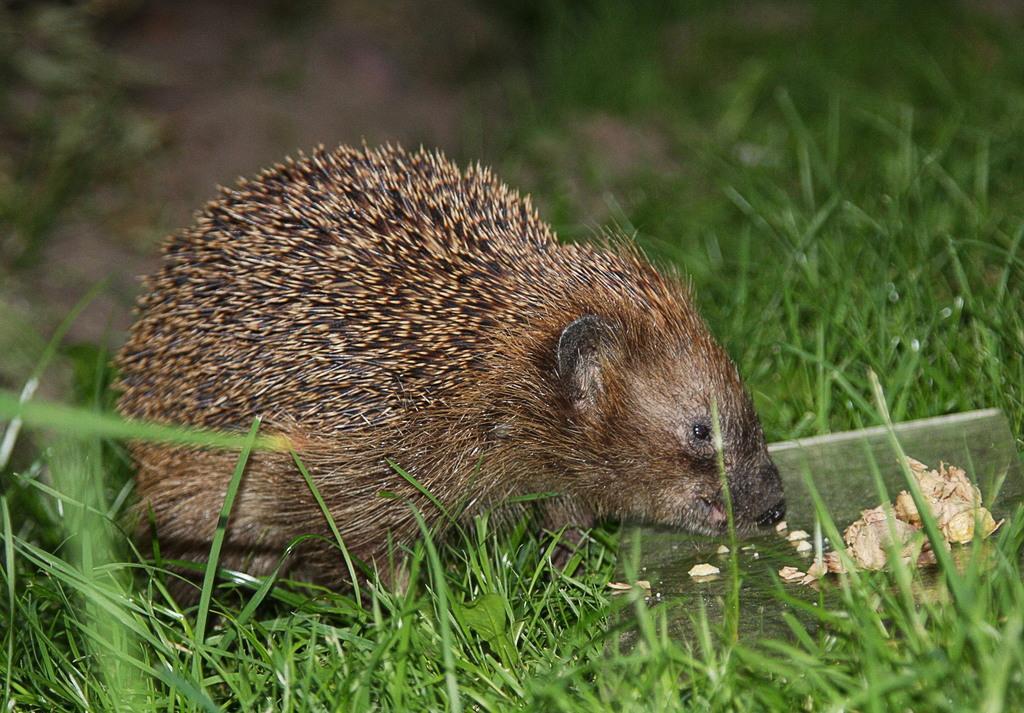Could you give a brief overview of what you see in this image? In this image we can see an animal on the grass. There is a blur background. 